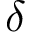Convert formula to latex. <formula><loc_0><loc_0><loc_500><loc_500>\delta</formula> 